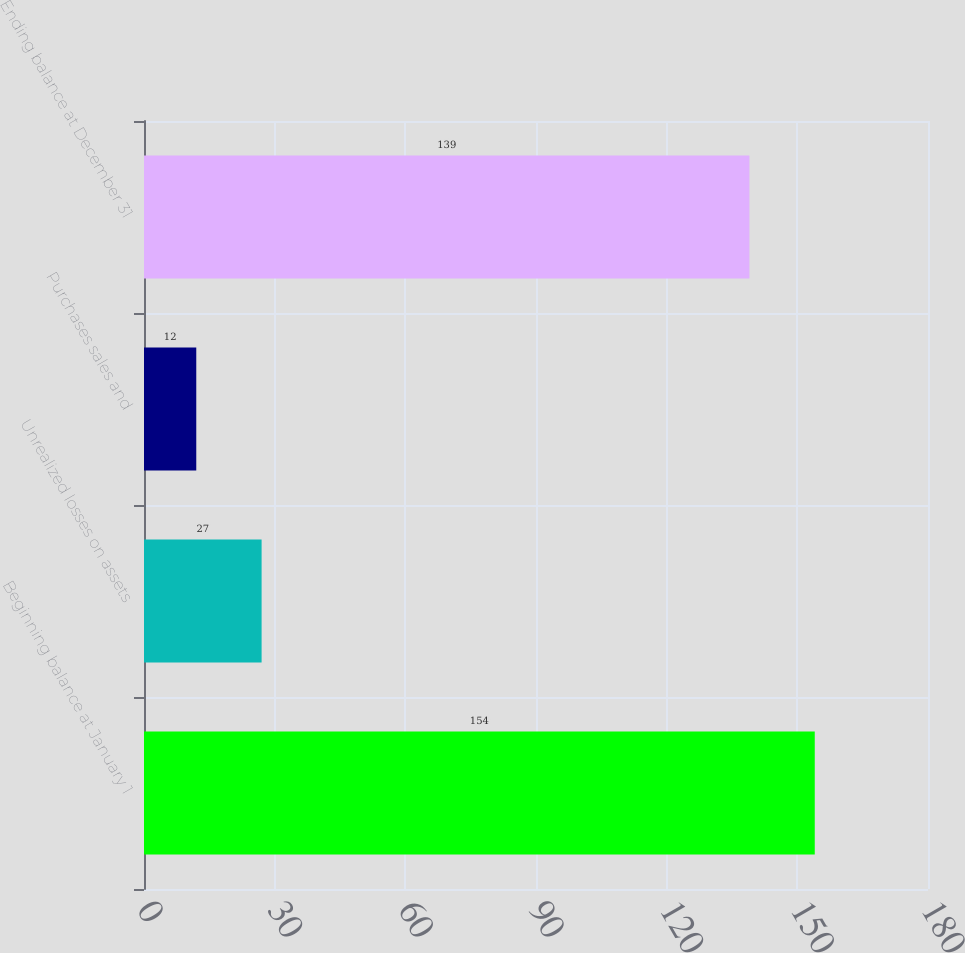<chart> <loc_0><loc_0><loc_500><loc_500><bar_chart><fcel>Beginning balance at January 1<fcel>Unrealized losses on assets<fcel>Purchases sales and<fcel>Ending balance at December 31<nl><fcel>154<fcel>27<fcel>12<fcel>139<nl></chart> 